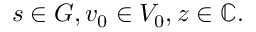<formula> <loc_0><loc_0><loc_500><loc_500>s \in G , v _ { 0 } \in V _ { 0 } , z \in \mathbb { C } .</formula> 